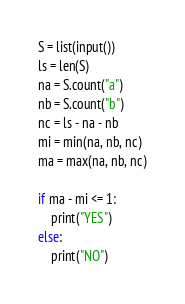Convert code to text. <code><loc_0><loc_0><loc_500><loc_500><_Python_>S = list(input())
ls = len(S)
na = S.count("a")
nb = S.count("b")
nc = ls - na - nb
mi = min(na, nb, nc)
ma = max(na, nb, nc)

if ma - mi <= 1:
    print("YES")
else:
    print("NO")</code> 